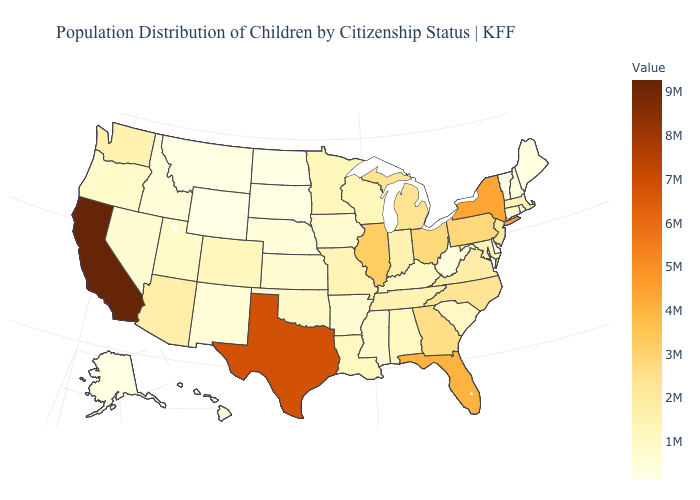Does South Carolina have a higher value than Wyoming?
Quick response, please. Yes. Does the map have missing data?
Answer briefly. No. Does Nevada have the highest value in the West?
Answer briefly. No. Does Maine have the highest value in the Northeast?
Write a very short answer. No. Among the states that border California , does Arizona have the lowest value?
Give a very brief answer. No. Is the legend a continuous bar?
Be succinct. Yes. Among the states that border Vermont , does Massachusetts have the lowest value?
Concise answer only. No. 